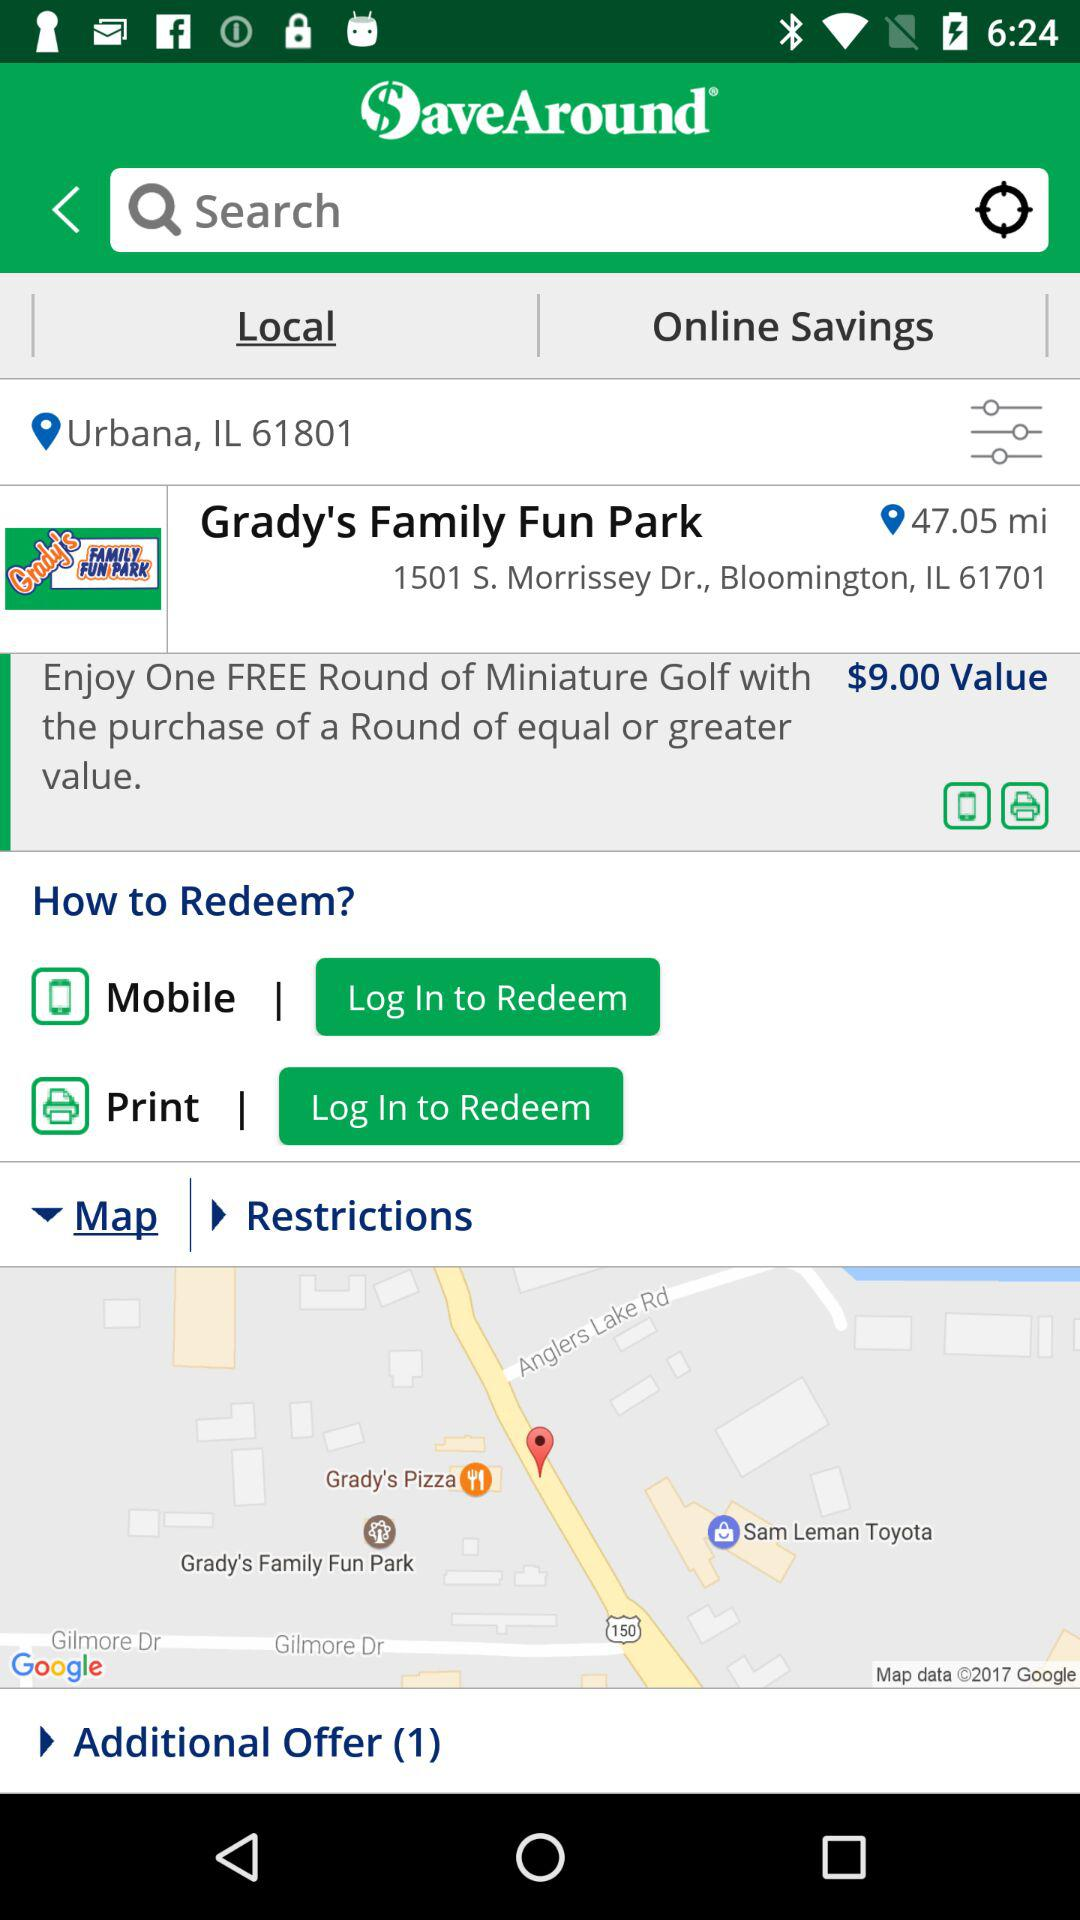What is the current location? The current location is Urbana, IL 61801. 